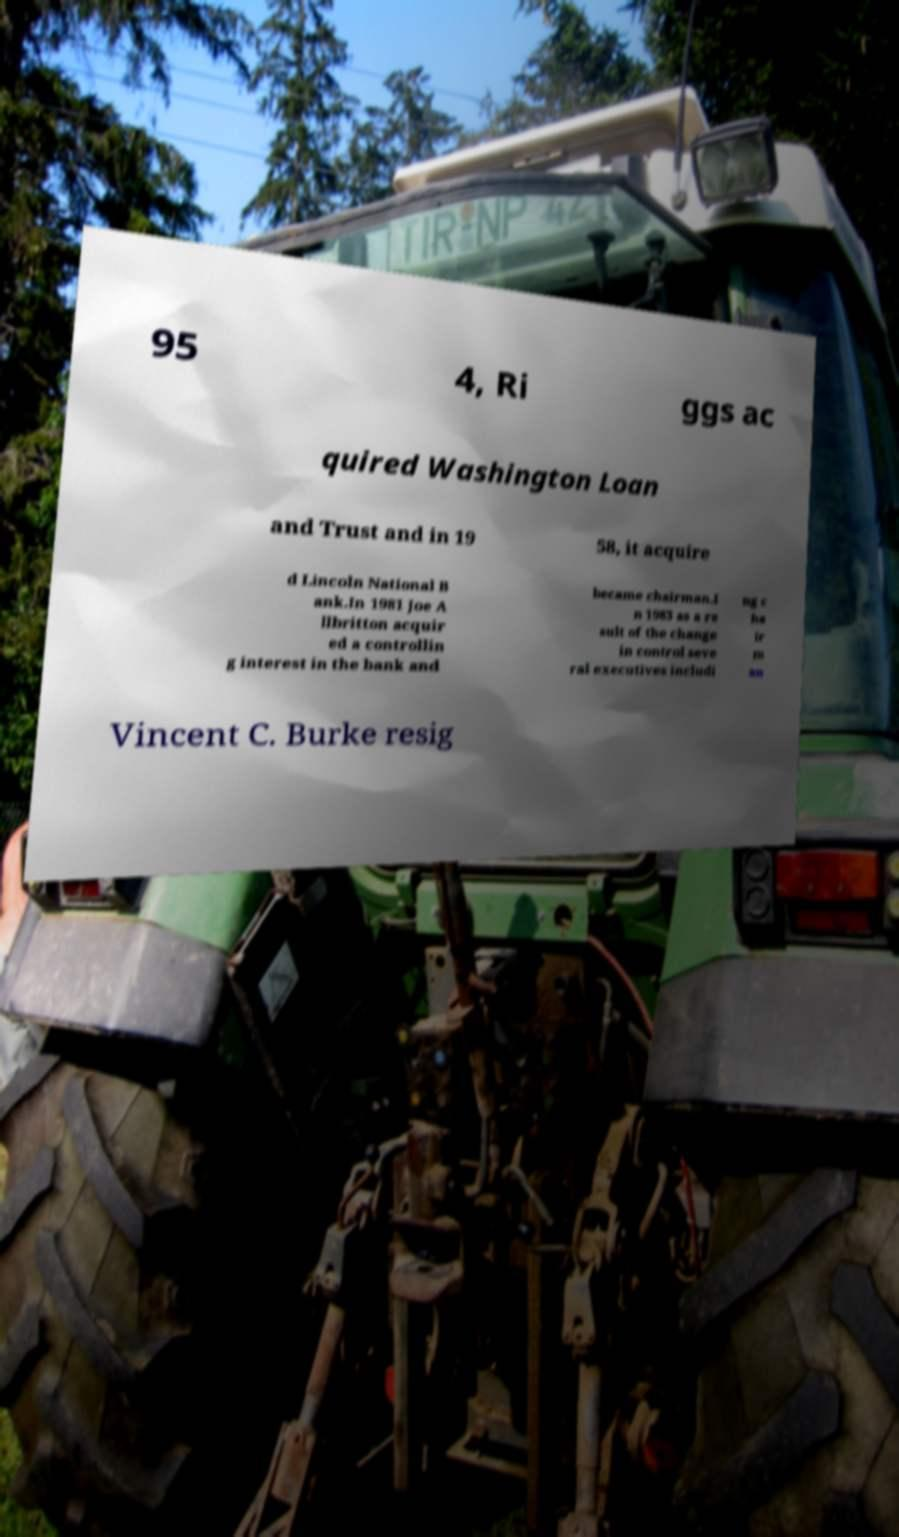Please read and relay the text visible in this image. What does it say? 95 4, Ri ggs ac quired Washington Loan and Trust and in 19 58, it acquire d Lincoln National B ank.In 1981 Joe A llbritton acquir ed a controllin g interest in the bank and became chairman.I n 1983 as a re sult of the change in control seve ral executives includi ng c ha ir m an Vincent C. Burke resig 